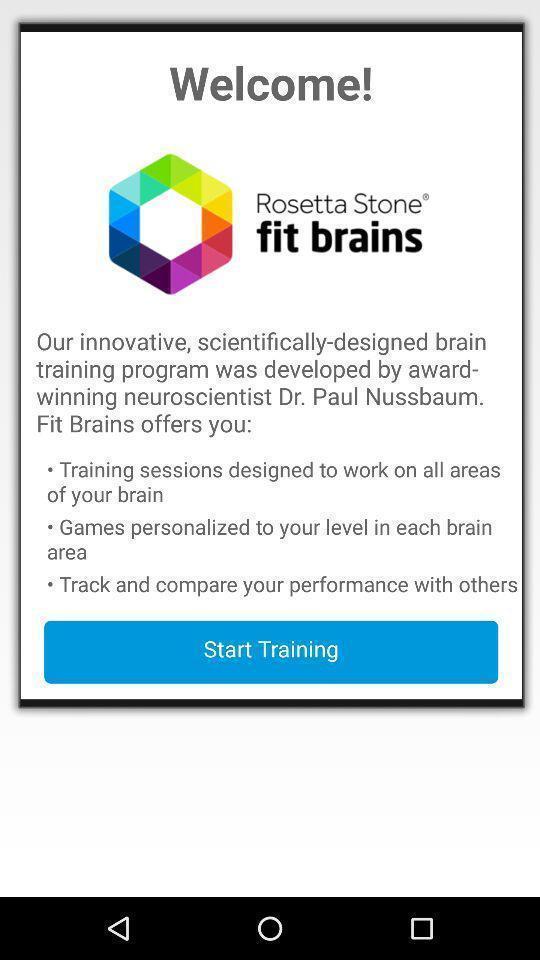Tell me what you see in this picture. Welcome page of a learning app. 